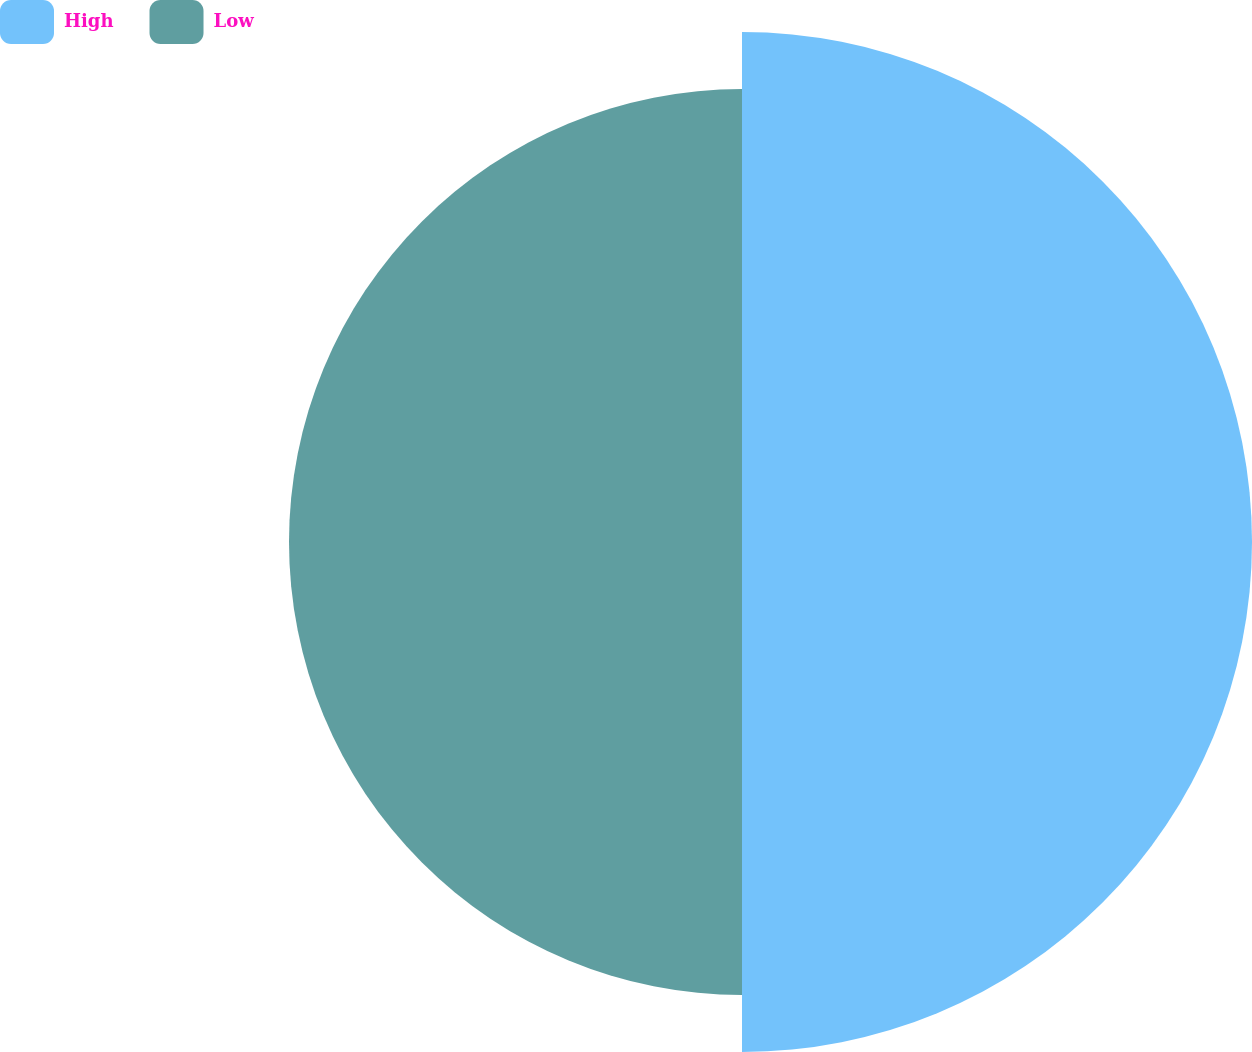<chart> <loc_0><loc_0><loc_500><loc_500><pie_chart><fcel>High<fcel>Low<nl><fcel>52.96%<fcel>47.04%<nl></chart> 